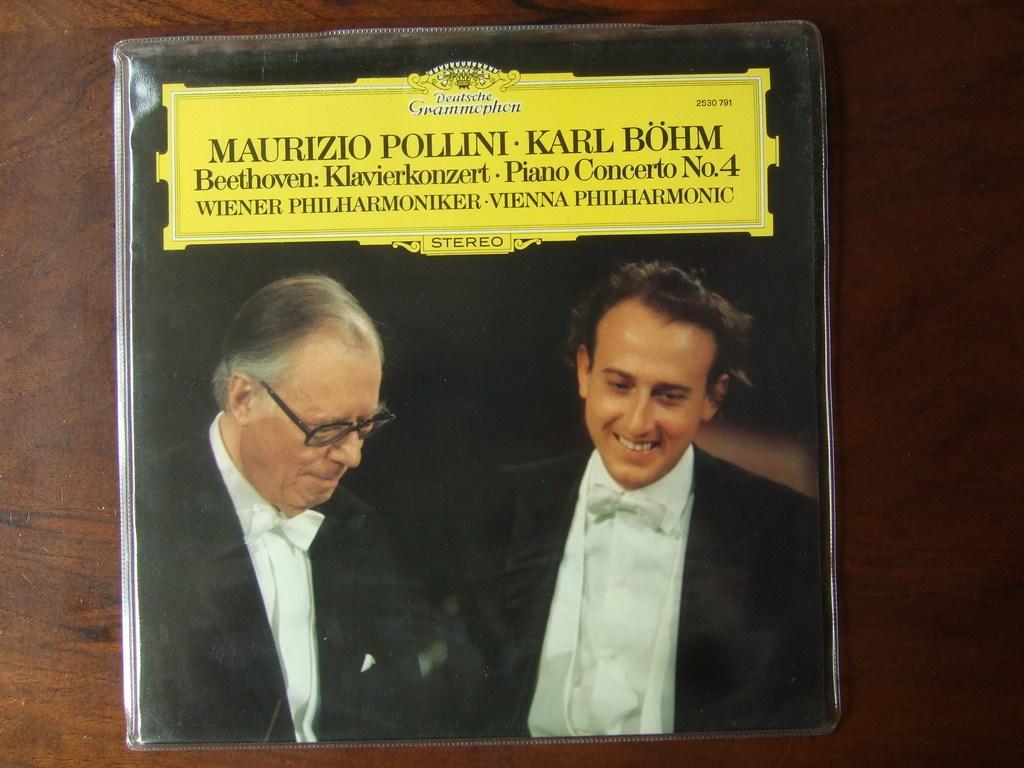Describe this image in one or two sentences. In this image I can see two persons photo and text may be on the floor. This image is taken may be in a room. 